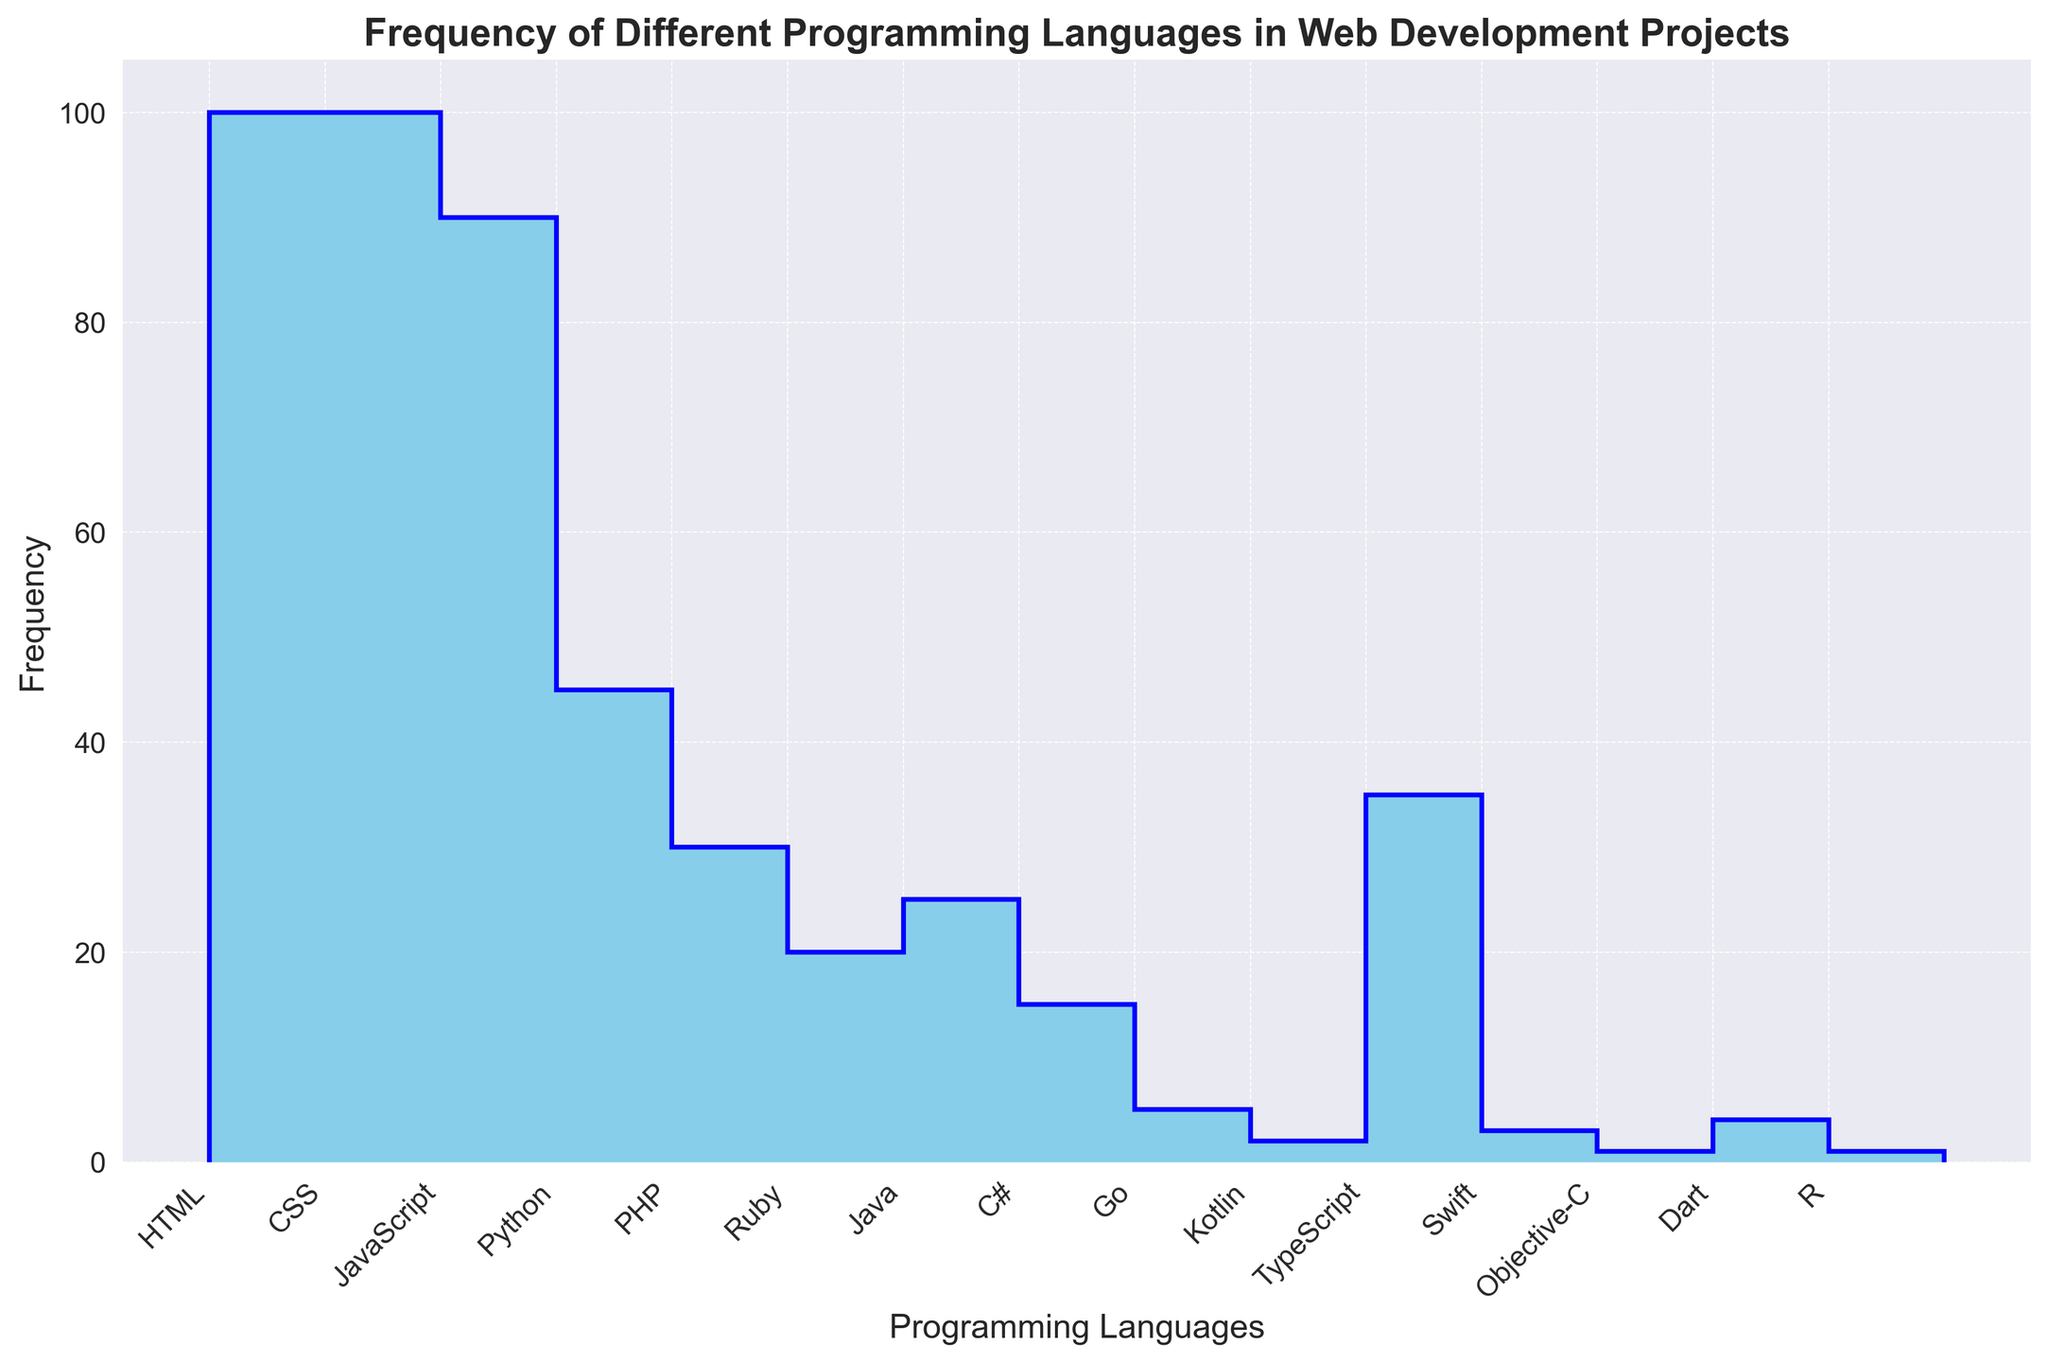Which programming language has the highest frequency? The highest bar in the stairs plot represents the language with the highest frequency. From the figure, HTML and CSS have the tallest bars.
Answer: HTML and CSS Which programming language has the lowest frequency? The shortest bar in the stairs plot indicates the language with the lowest frequency. From the figure, Objective-C and R have the shortest bars.
Answer: Objective-C and R How many programming languages have a frequency greater than 30? Count the number of bars with a height greater than 30. They are HTML, CSS, JavaScript, TypeScript, and Python.
Answer: 5 What is the sum of the frequencies for JavaScript and Python? Locate the frequencies for JavaScript (90) and Python (45) and add them together: 90 + 45 = 135.
Answer: 135 Which language has a frequency that is half of Python's frequency? Python has a frequency of 45. Half of 45 is 22.5. The closest frequency is Ruby with 20 in the plot.
Answer: Ruby How does the frequency of TypeScript compare to that of PHP? TypeScript has a frequency of 35, while PHP has a frequency of 30. 35 is greater than 30.
Answer: TypeScript is greater Which language has a frequency between 20 and 40? Identify languages with bars between the heights representing 20 and 40. The language is TypeScript.
Answer: TypeScript What's the difference in frequency between Java and Swift? Java has a frequency of 25, and Swift has 3. The difference is 25 - 3 = 22.
Answer: 22 What is the average frequency of the three least used programming languages? The three least used languages are Objective-C, R, and Kotlin with frequencies 1, 1, and 2 respectively. The average is (1 + 1 + 2) / 3 = 4 / 3 ≈ 1.33.
Answer: ≈1.33 What is the combined frequency of all languages with a frequency above 50? The languages are HTML, CSS, and JavaScript with frequencies 100, 100, and 90 respectively. Sum them: 100 + 100 + 90 = 290.
Answer: 290 